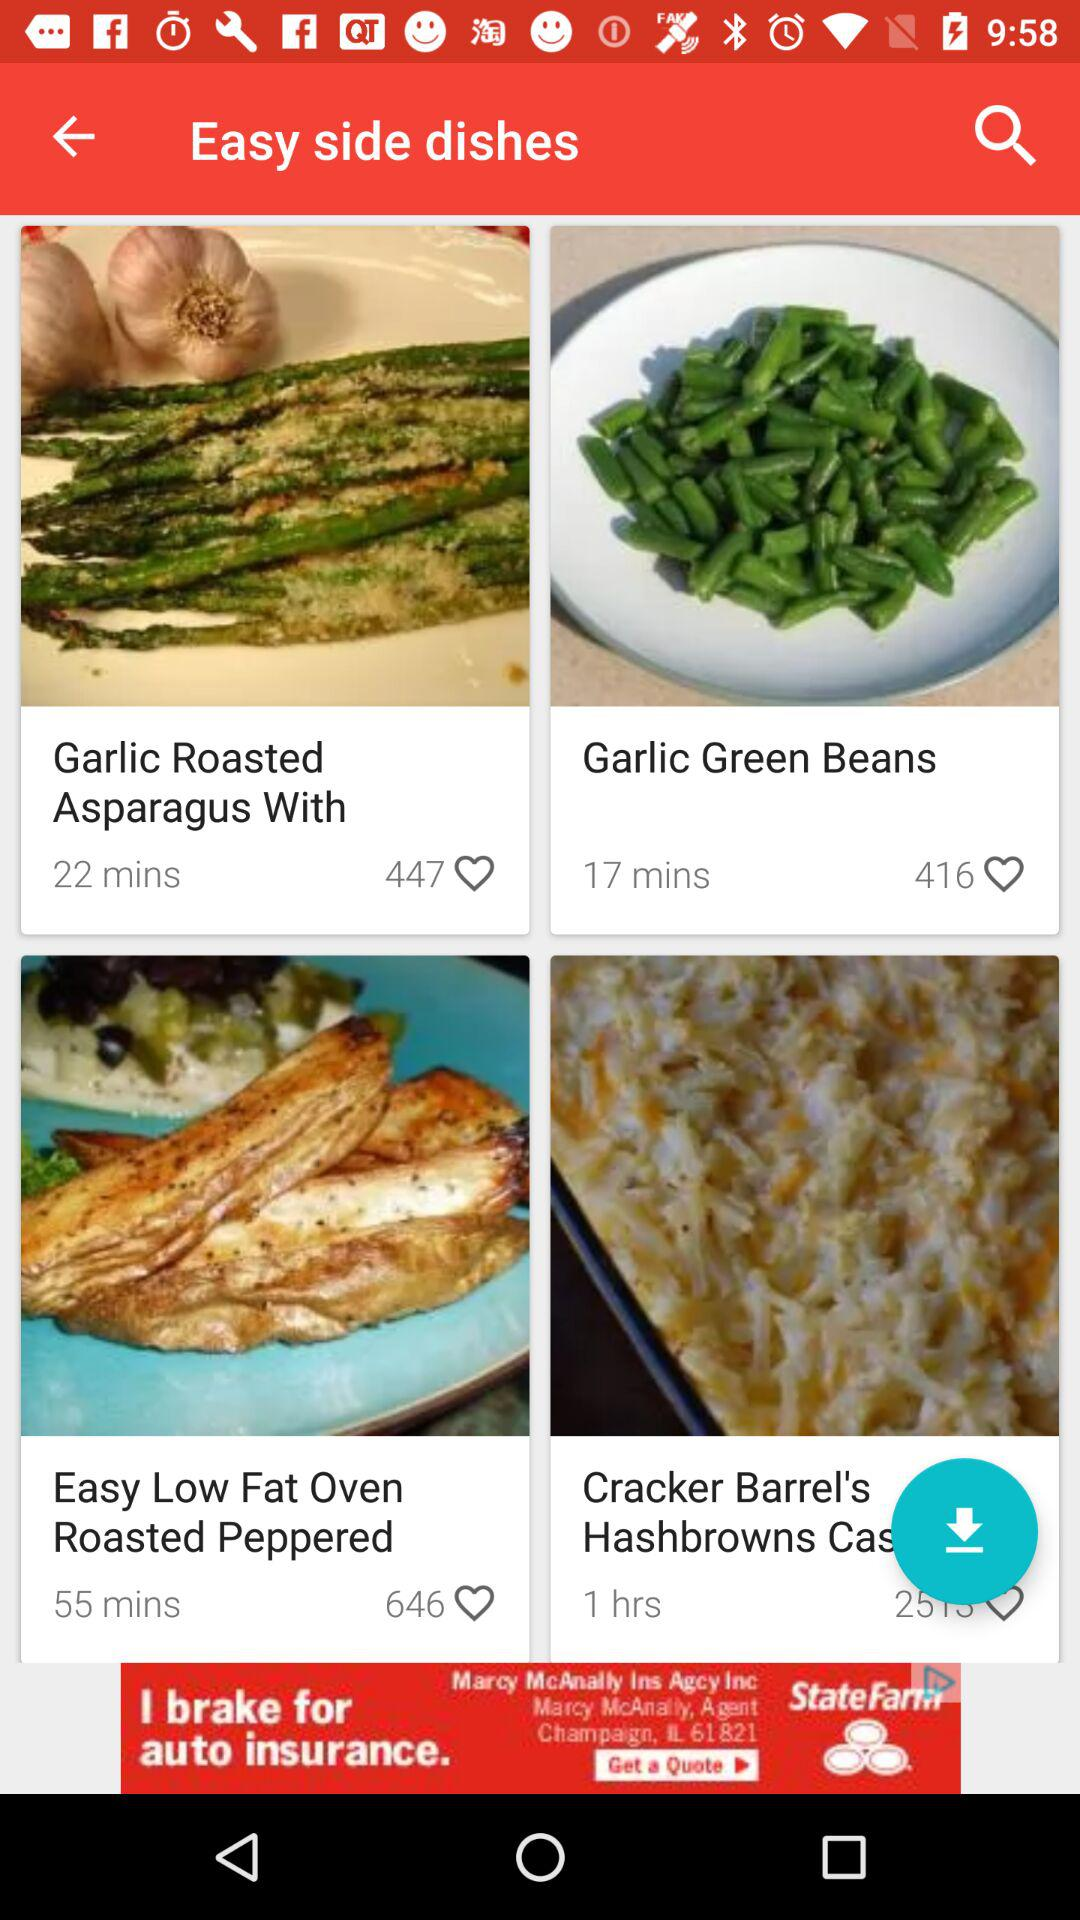What is the preparation duration of the "Garlic Green Beans" dish? The preparation duration of the "Garlic Green Beans" dish is 17 minutes. 